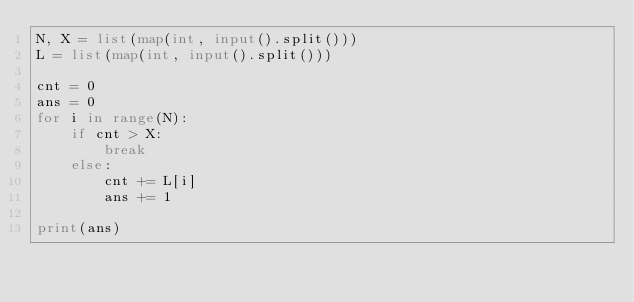Convert code to text. <code><loc_0><loc_0><loc_500><loc_500><_Python_>N, X = list(map(int, input().split()))
L = list(map(int, input().split()))

cnt = 0
ans = 0
for i in range(N):
    if cnt > X:
        break
    else:
        cnt += L[i]
        ans += 1

print(ans)
</code> 